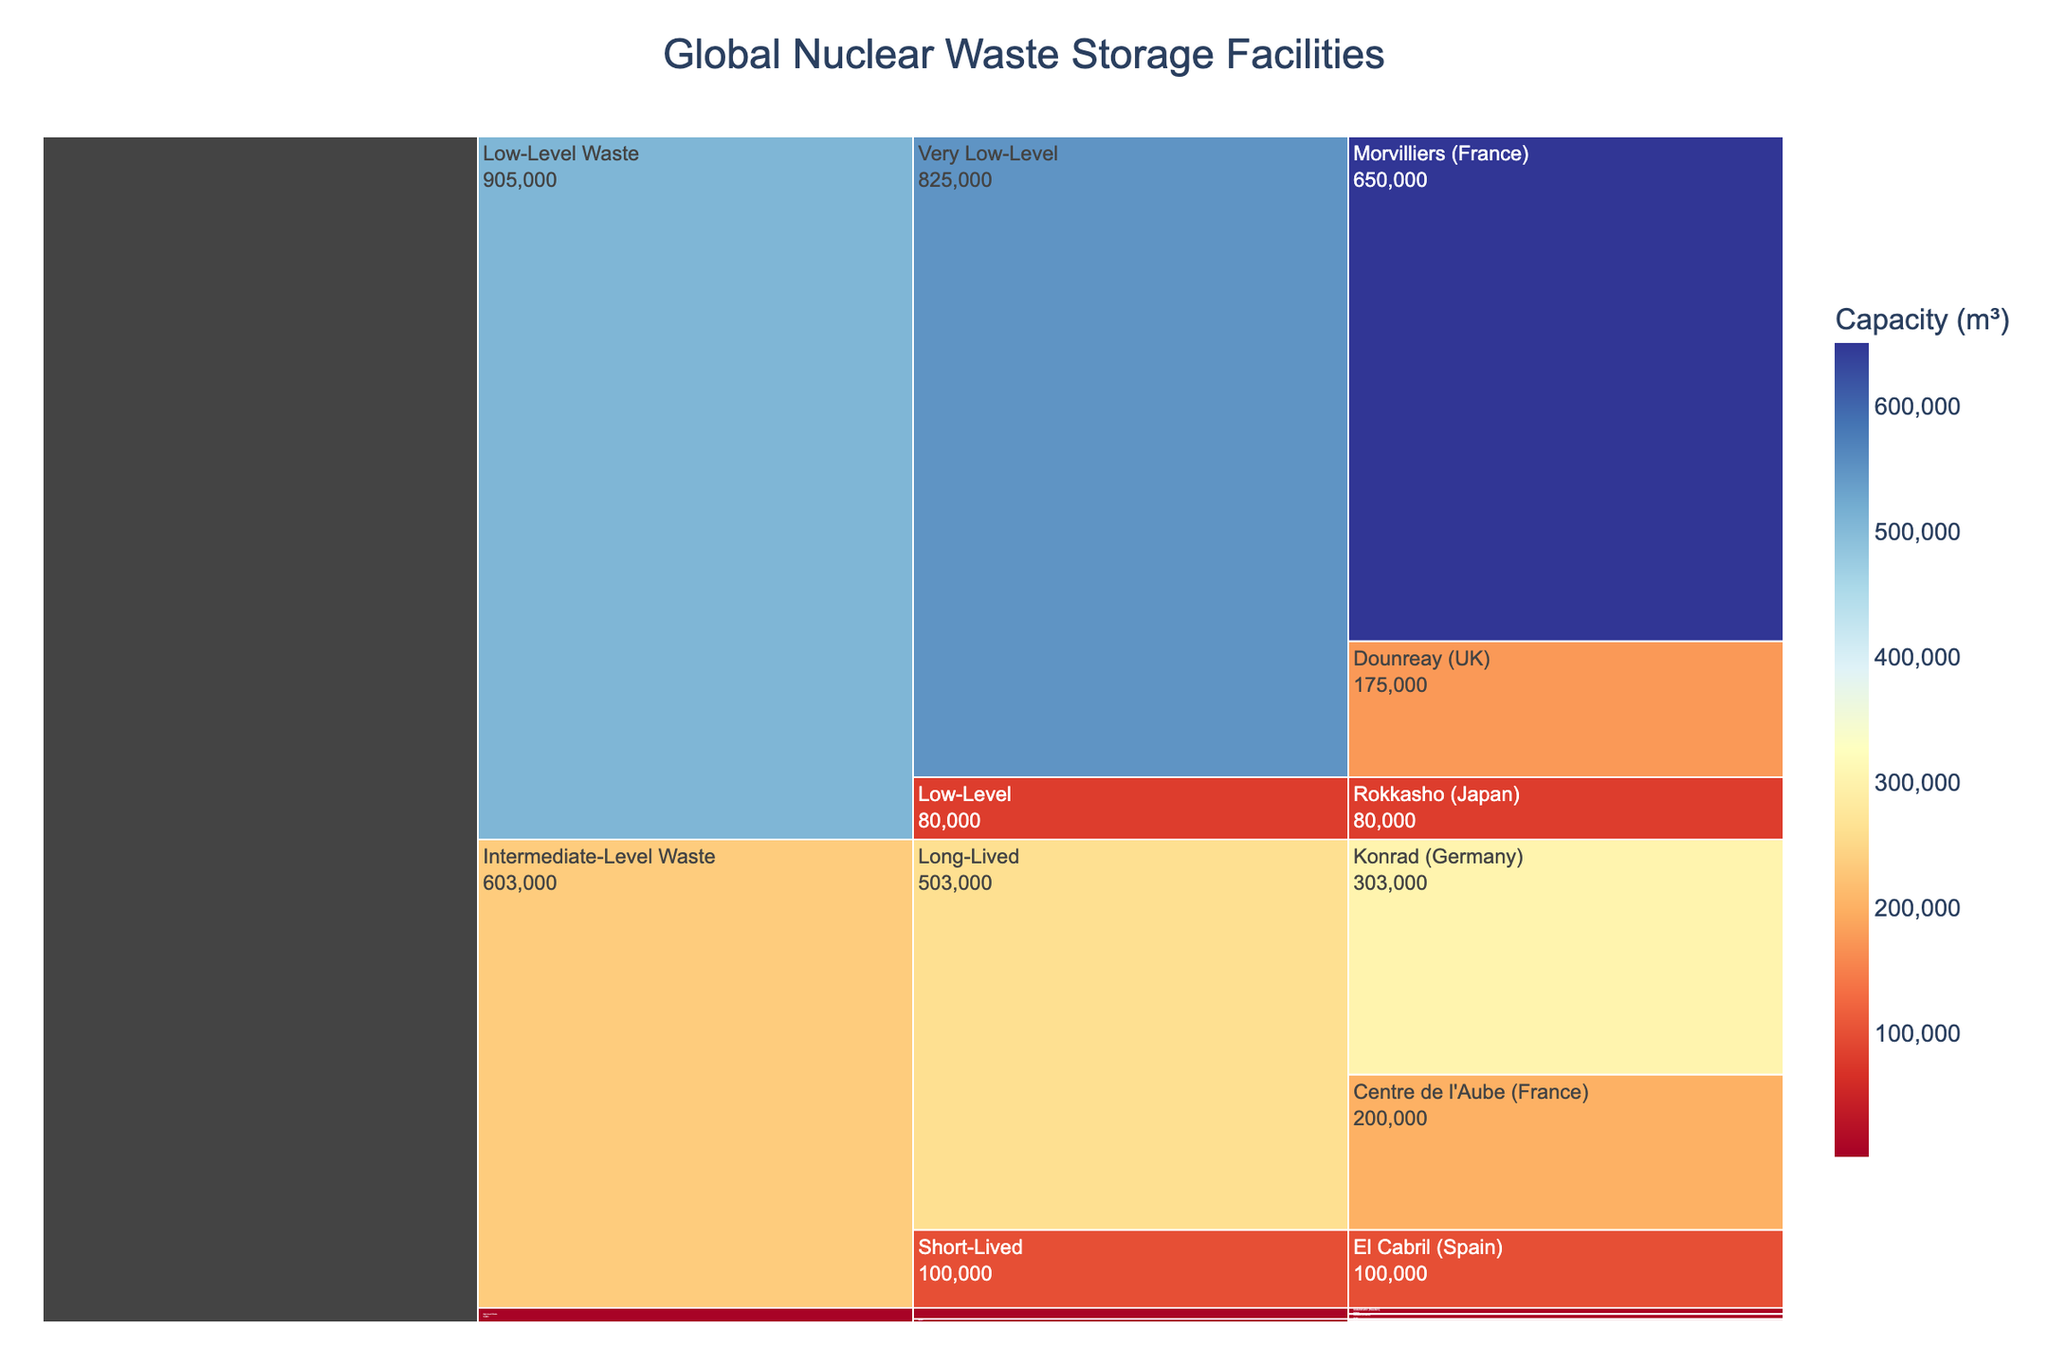How many categories of nuclear waste are represented in the icicle chart? The icicle chart has three distinct top-level categories: High-Level Waste, Intermediate-Level Waste, and Low-Level Waste.
Answer: 3 Which facility has the largest capacity for Intermediate-Level Waste? Under the Intermediate-Level Waste category, the largest capacity is represented by the Konrad facility in Germany with a capacity of 303,000 m³.
Answer: Konrad (Germany) Compare the capacities of the High-Level Waste Vitrified facilities. Which facility has the higher capacity and by how much? The Vitrified facilities are La Hague (France) at 2,500 m³ and Sellafield (UK) at 1,800 m³. The capacity difference is 2,500 - 1,800 = 700 m³.
Answer: La Hague by 700 m³ What is the combined capacity of all High-Level Waste facilities? The capacities are 2,500 m³ (La Hague), 1,800 m³ (Sellafield), 8,000 m³ (Oskarshamn), and 6,500 m³ (Olkiluoto). The combined capacity is 2,500 + 1,800 + 8,000 + 6,500 = 18,800 m³.
Answer: 18,800 m³ Which Low-Level Waste facility has the smallest capacity, and what is it? The Low-Level Waste facilities are categorized into Very Low-Level and Low-Level. Among these, the Rokkasho (Japan) facility has the smallest capacity of 80,000 m³.
Answer: Rokkasho (Japan) How does the capacity of Centre de l'Aube (France) compare to the combined capacity of all Intermediate-Level Waste Short-Lived facilities? Centre de l'Aube has a capacity of 200,000 m³. El Cabril (Spain), the only Intermediate-Level Waste Short-Lived facility, has a capacity of 100,000 m³. So, Centre de l'Aube's capacity is double that of El Cabril's.
Answer: Centre de l'Aube is double What proportion of the total Intermediate-Level Waste capacity is attributed to long-lived versus short-lived waste? The total Intermediate-Level Waste capacity is the sum of long-lived and short-lived capacities: 200,000 m³ (Centre de l'Aube) + 303,000 m³ (Konrad) = 503,000 m³ for long-lived, and 100,000 m³ for short-lived. The proportion is 503,000 / (503,000 + 100,000) for long-lived and 100,000 / (503,000 + 100,000) for short-lived.
Answer: 83.5% long-lived, 16.5% short-lived Which category contributes the most to the global nuclear waste storage capacity? The capacities are summed by category: High-Level Waste = 18,800 m³, Intermediate-Level Waste = 603,000 m³ (200,000 + 303,000 + 100,000), and Low-Level Waste = 905,000 m³ (650,000 + 80,000 + 175,000). The largest contribution is from Low-Level Waste.
Answer: Low-Level Waste Identify the country with the highest total nuclear waste storage capacity and specify the total capacity. Adding up the capacities for each country's facilities, France has La Hague (2,500 m³) + Centre de l'Aube (200,000 m³) + Morvilliers (650,000 m³) resulting in 852,500 m³. This is the highest among all countries listed.
Answer: France with 852,500 m³ 